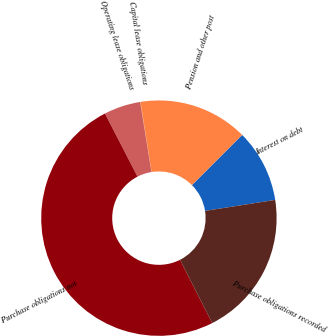<chart> <loc_0><loc_0><loc_500><loc_500><pie_chart><fcel>Interest on debt<fcel>Pension and other post<fcel>Capital lease obligations<fcel>Operating lease obligations<fcel>Purchase obligations not<fcel>Purchase obligations recorded<nl><fcel>10.02%<fcel>15.0%<fcel>0.05%<fcel>5.03%<fcel>49.9%<fcel>19.99%<nl></chart> 